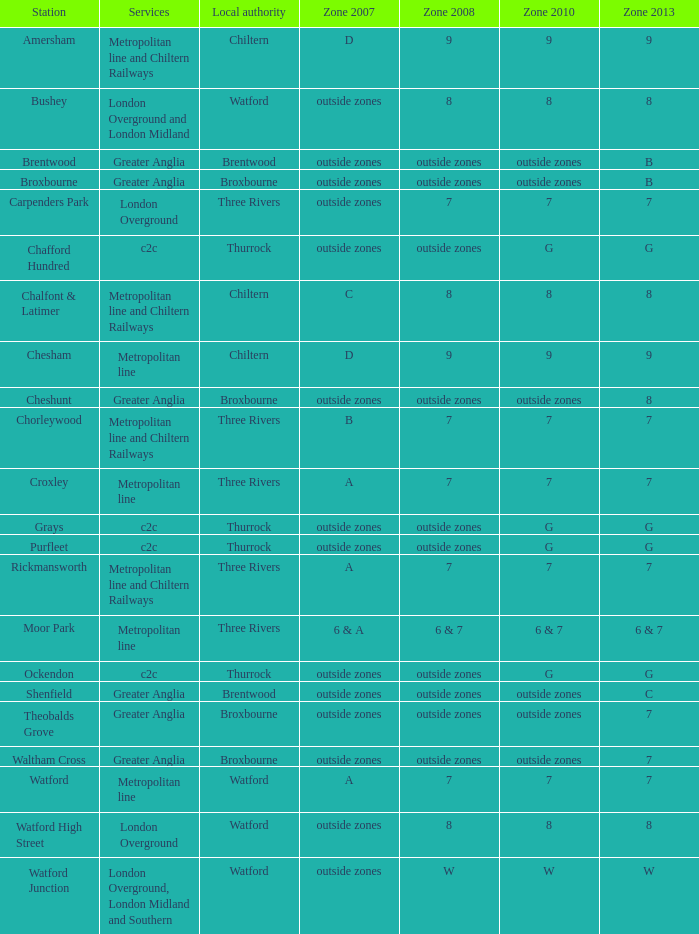Which Local authority has a Zone 2007 of outside zones, and a Zone 2008 of outside zones, and a Zone 2010 of outside zones, and a Station of waltham cross? Broxbourne. 